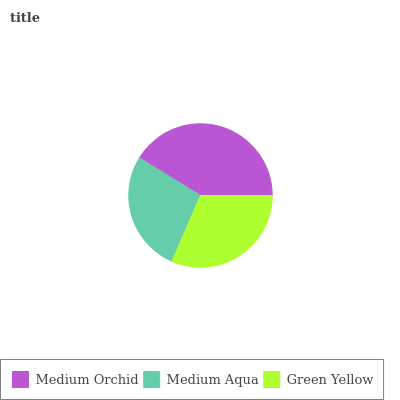Is Medium Aqua the minimum?
Answer yes or no. Yes. Is Medium Orchid the maximum?
Answer yes or no. Yes. Is Green Yellow the minimum?
Answer yes or no. No. Is Green Yellow the maximum?
Answer yes or no. No. Is Green Yellow greater than Medium Aqua?
Answer yes or no. Yes. Is Medium Aqua less than Green Yellow?
Answer yes or no. Yes. Is Medium Aqua greater than Green Yellow?
Answer yes or no. No. Is Green Yellow less than Medium Aqua?
Answer yes or no. No. Is Green Yellow the high median?
Answer yes or no. Yes. Is Green Yellow the low median?
Answer yes or no. Yes. Is Medium Orchid the high median?
Answer yes or no. No. Is Medium Orchid the low median?
Answer yes or no. No. 